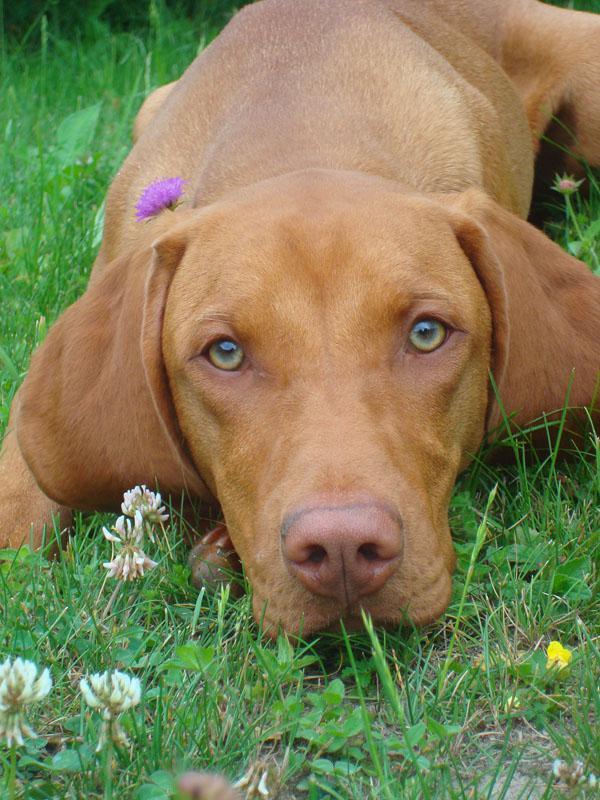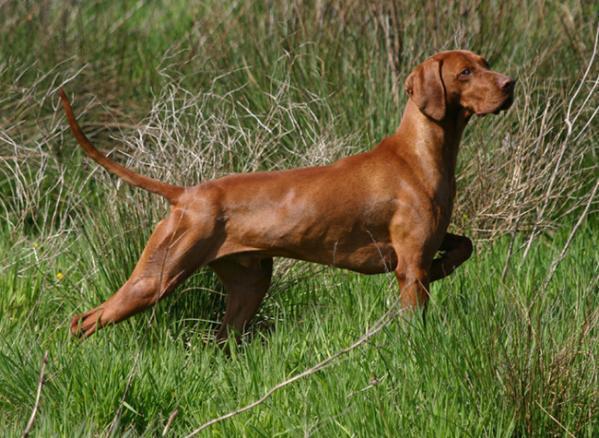The first image is the image on the left, the second image is the image on the right. For the images displayed, is the sentence "There are two dogs." factually correct? Answer yes or no. Yes. The first image is the image on the left, the second image is the image on the right. Considering the images on both sides, is "Each image includes at least one red-orange dog in a standing pose, at least two adult dogs in total are shown, and no other poses are shown." valid? Answer yes or no. No. 